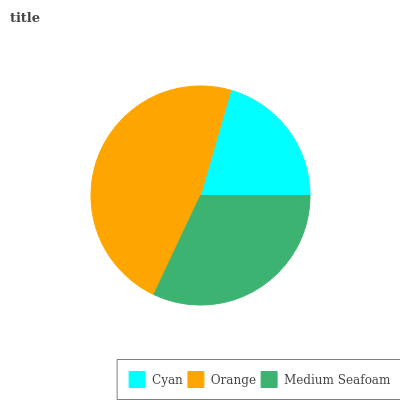Is Cyan the minimum?
Answer yes or no. Yes. Is Orange the maximum?
Answer yes or no. Yes. Is Medium Seafoam the minimum?
Answer yes or no. No. Is Medium Seafoam the maximum?
Answer yes or no. No. Is Orange greater than Medium Seafoam?
Answer yes or no. Yes. Is Medium Seafoam less than Orange?
Answer yes or no. Yes. Is Medium Seafoam greater than Orange?
Answer yes or no. No. Is Orange less than Medium Seafoam?
Answer yes or no. No. Is Medium Seafoam the high median?
Answer yes or no. Yes. Is Medium Seafoam the low median?
Answer yes or no. Yes. Is Orange the high median?
Answer yes or no. No. Is Cyan the low median?
Answer yes or no. No. 